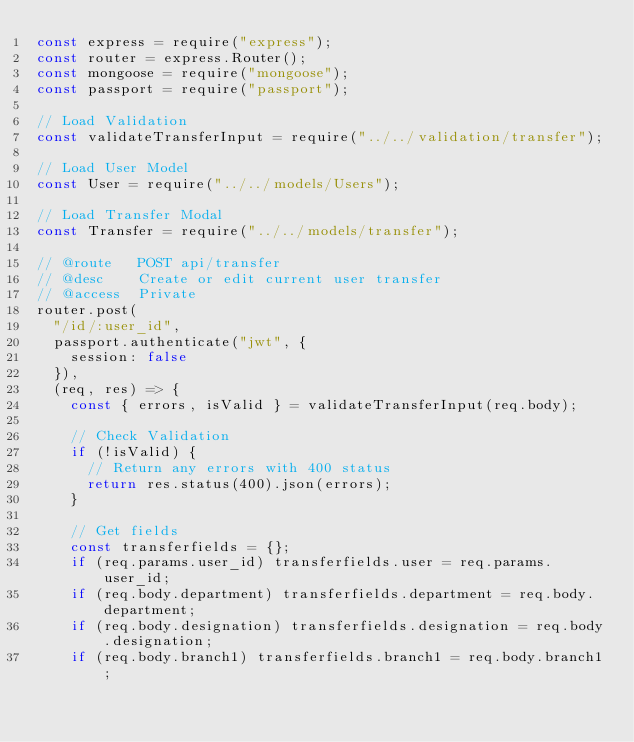Convert code to text. <code><loc_0><loc_0><loc_500><loc_500><_JavaScript_>const express = require("express");
const router = express.Router();
const mongoose = require("mongoose");
const passport = require("passport");

// Load Validation
const validateTransferInput = require("../../validation/transfer");

// Load User Model
const User = require("../../models/Users");

// Load Transfer Modal
const Transfer = require("../../models/transfer");

// @route   POST api/transfer
// @desc    Create or edit current user transfer
// @access  Private
router.post(
  "/id/:user_id",
  passport.authenticate("jwt", {
    session: false
  }),
  (req, res) => {
    const { errors, isValid } = validateTransferInput(req.body);

    // Check Validation
    if (!isValid) {
      // Return any errors with 400 status
      return res.status(400).json(errors);
    }

    // Get fields
    const transferfields = {};
    if (req.params.user_id) transferfields.user = req.params.user_id;
    if (req.body.department) transferfields.department = req.body.department;
    if (req.body.designation) transferfields.designation = req.body.designation;
    if (req.body.branch1) transferfields.branch1 = req.body.branch1;</code> 